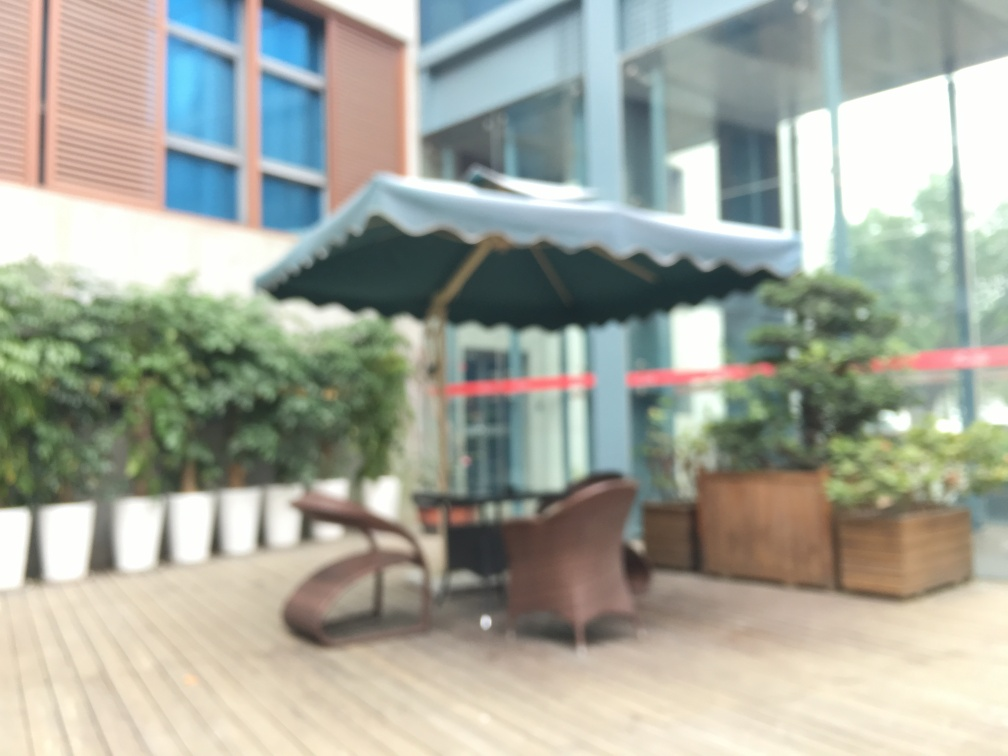Is there any noise present in the image? Yes, there appears to be a blurring effect over the entire image, which might be intentionally applied for artistic purposes or could be the result of a defocused camera lens. 